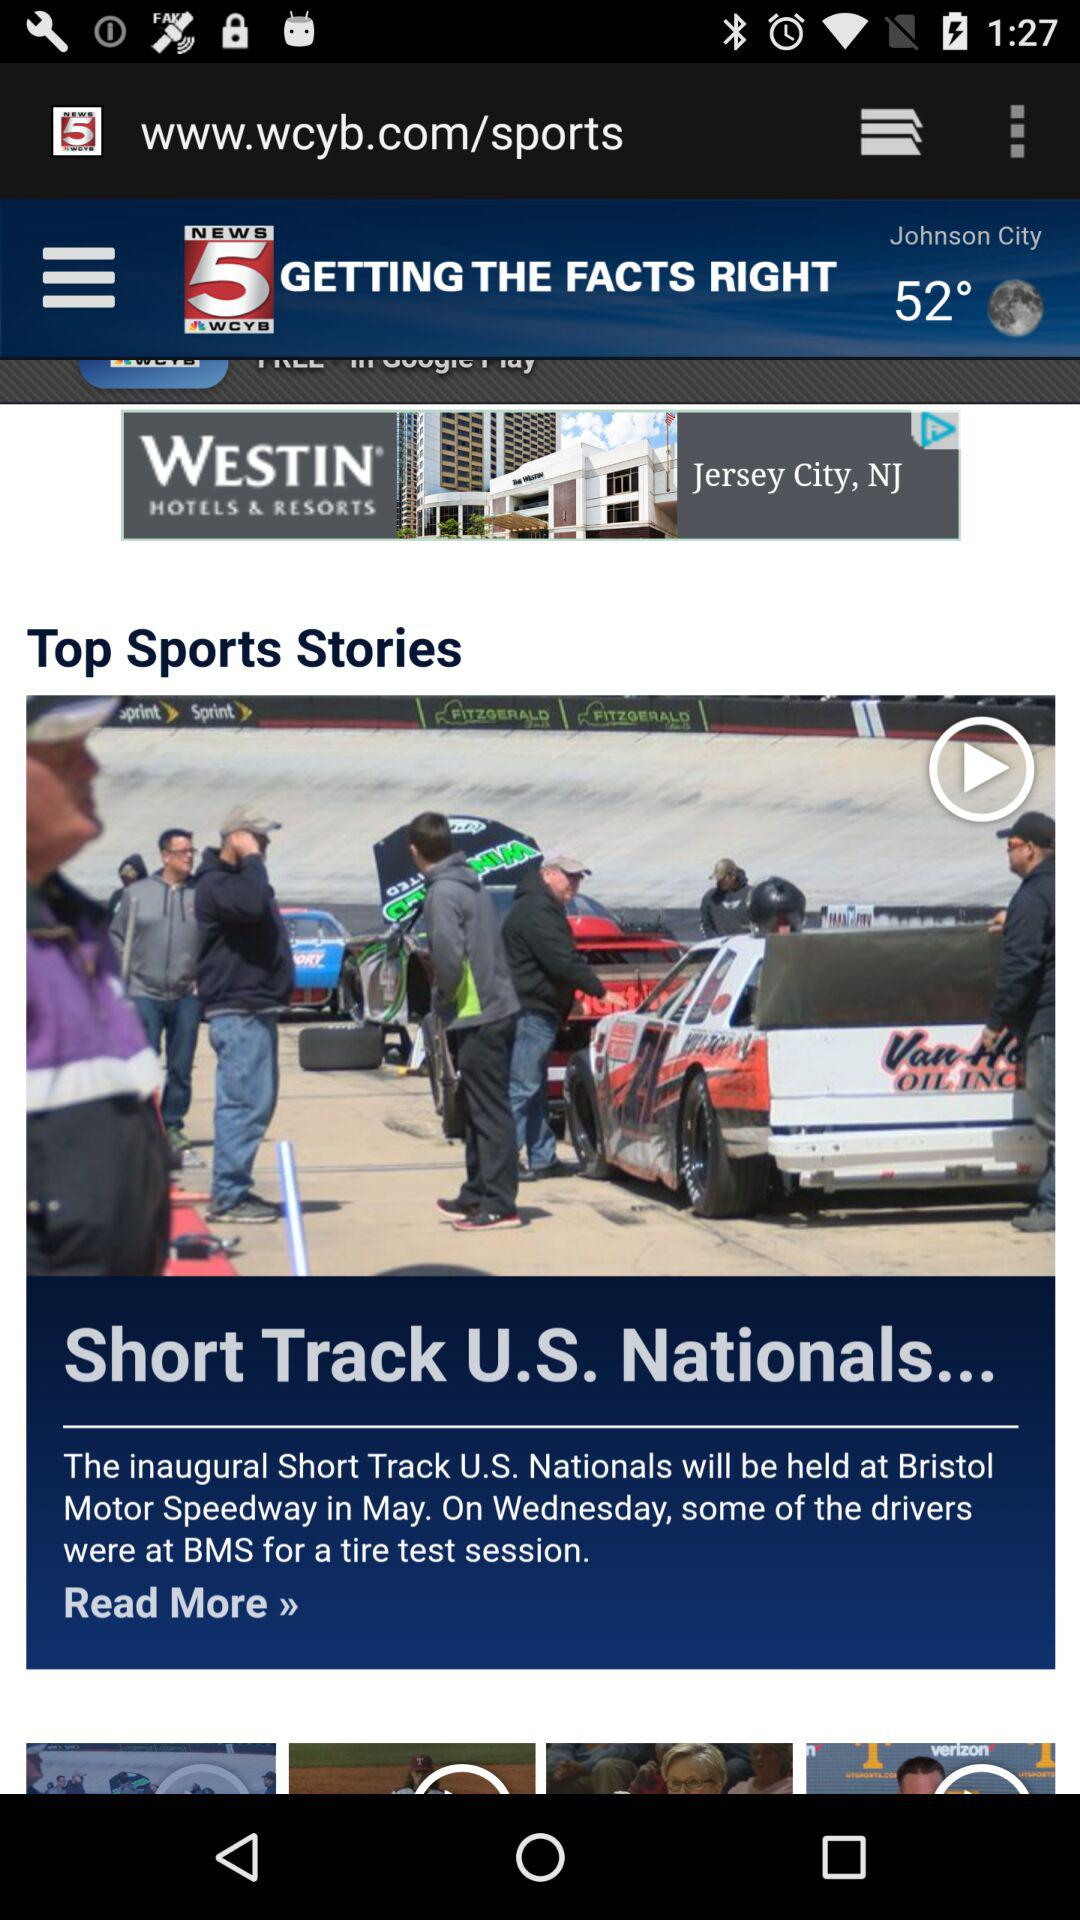How many degrees Fahrenheit is the temperature in Johnson City?
Answer the question using a single word or phrase. 52° 